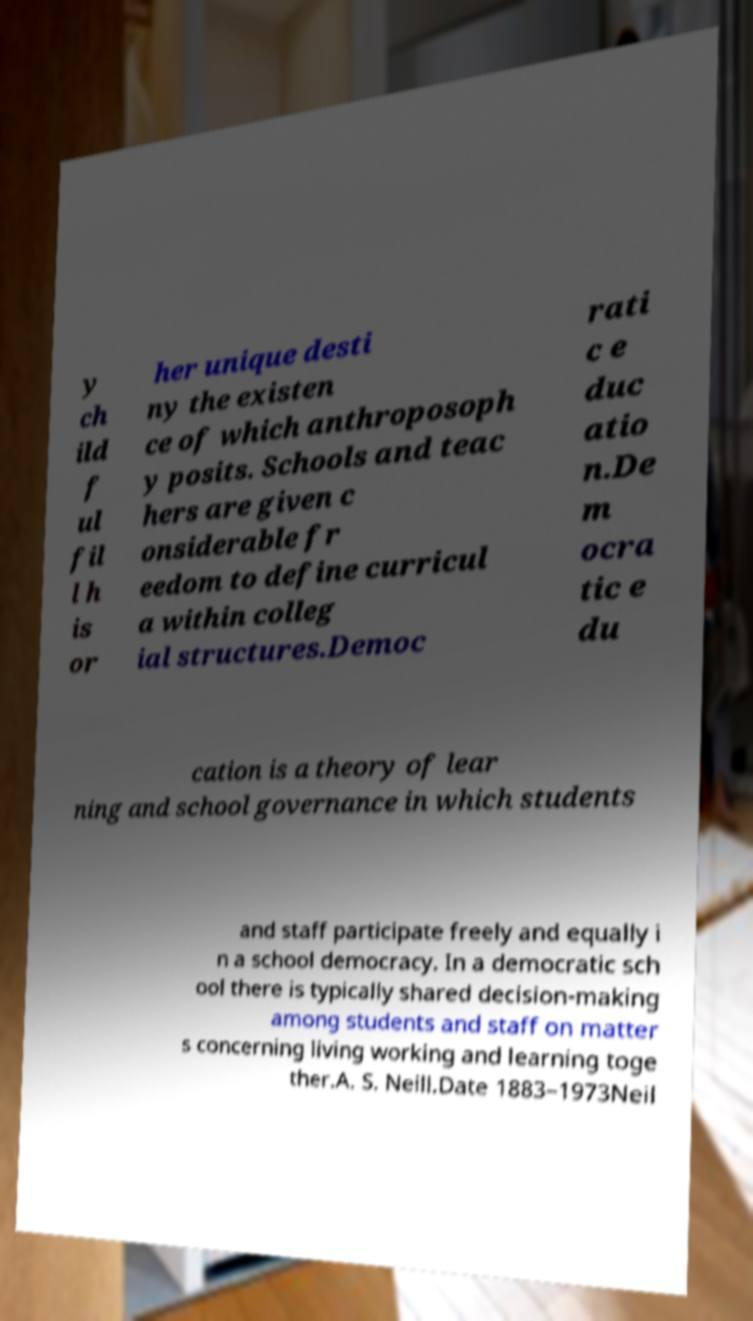There's text embedded in this image that I need extracted. Can you transcribe it verbatim? y ch ild f ul fil l h is or her unique desti ny the existen ce of which anthroposoph y posits. Schools and teac hers are given c onsiderable fr eedom to define curricul a within colleg ial structures.Democ rati c e duc atio n.De m ocra tic e du cation is a theory of lear ning and school governance in which students and staff participate freely and equally i n a school democracy. In a democratic sch ool there is typically shared decision-making among students and staff on matter s concerning living working and learning toge ther.A. S. Neill.Date 1883–1973Neil 